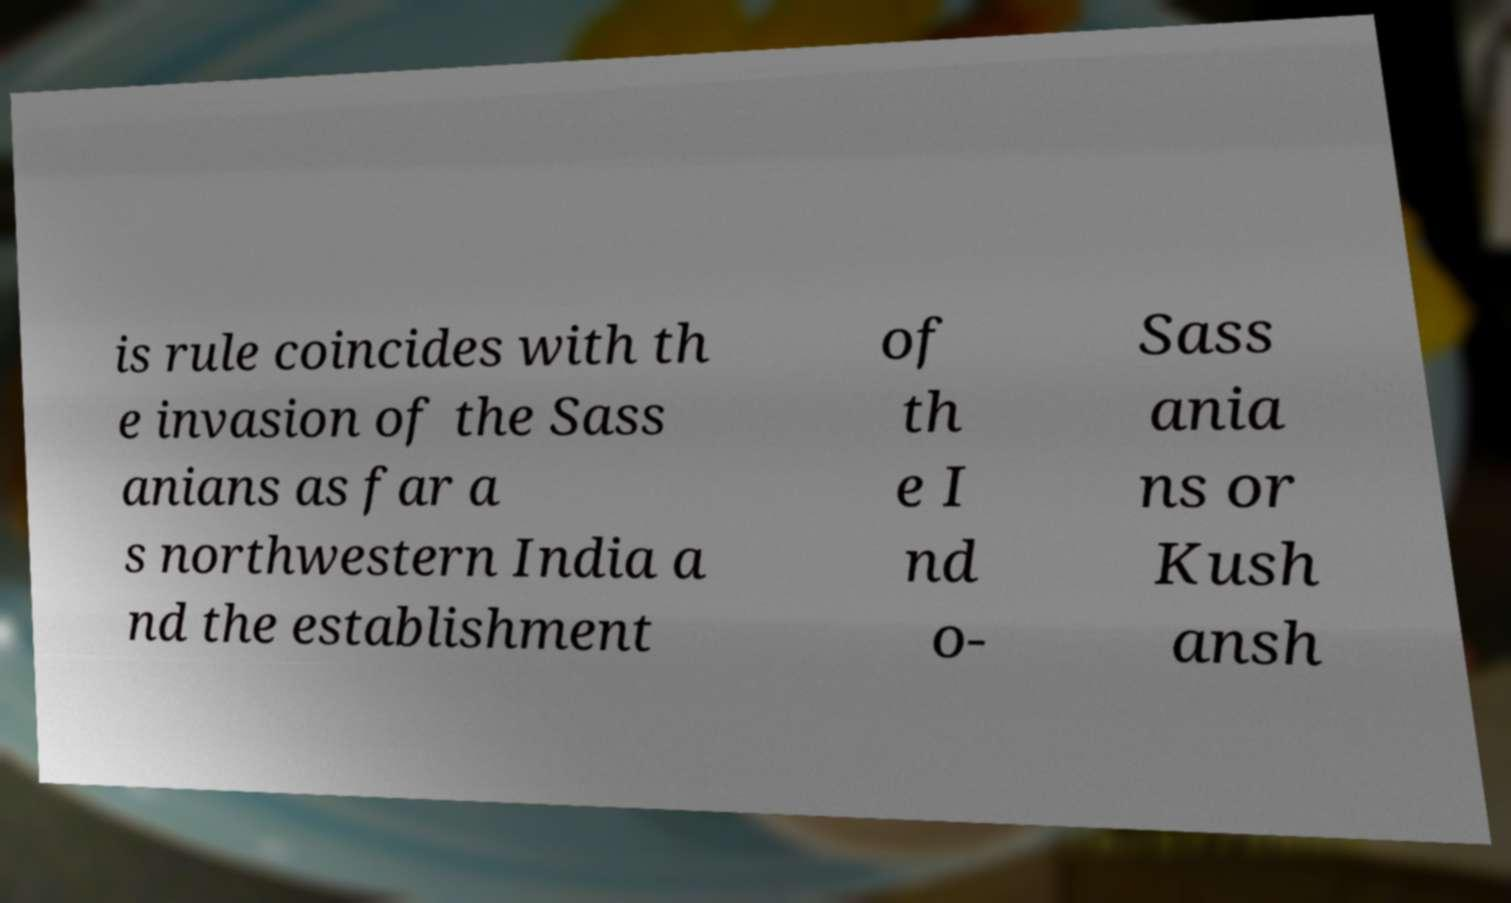Could you assist in decoding the text presented in this image and type it out clearly? is rule coincides with th e invasion of the Sass anians as far a s northwestern India a nd the establishment of th e I nd o- Sass ania ns or Kush ansh 